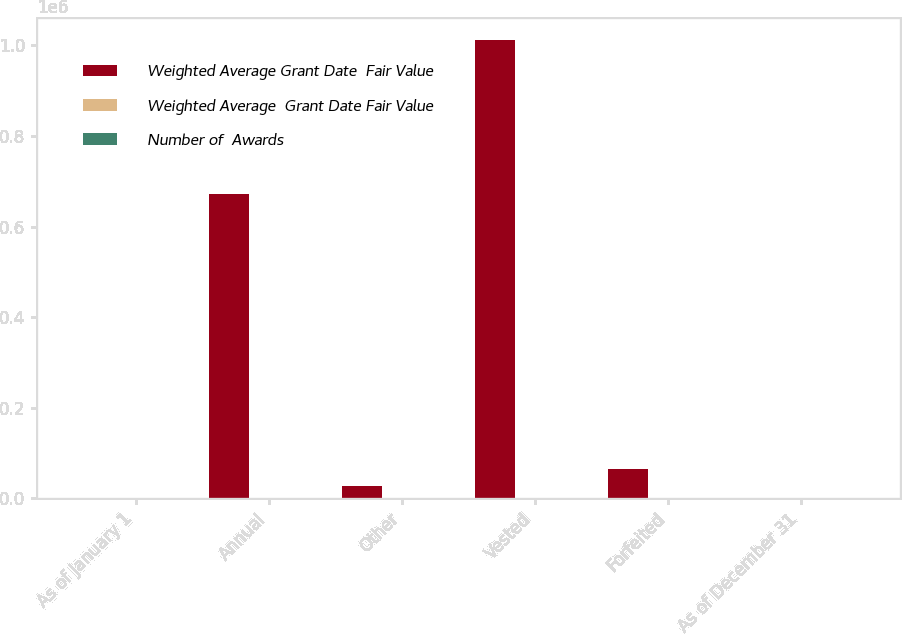Convert chart to OTSL. <chart><loc_0><loc_0><loc_500><loc_500><stacked_bar_chart><ecel><fcel>As of January 1<fcel>Annual<fcel>Other<fcel>Vested<fcel>Forfeited<fcel>As of December 31<nl><fcel>Weighted Average Grant Date  Fair Value<fcel>115.09<fcel>671204<fcel>26886<fcel>1.01061e+06<fcel>64176<fcel>115.09<nl><fcel>Weighted Average  Grant Date Fair Value<fcel>104.41<fcel>165.86<fcel>156.94<fcel>89.99<fcel>118.99<fcel>127.47<nl><fcel>Number of  Awards<fcel>85.17<fcel>101.57<fcel>111.19<fcel>79.93<fcel>90.82<fcel>92.31<nl></chart> 